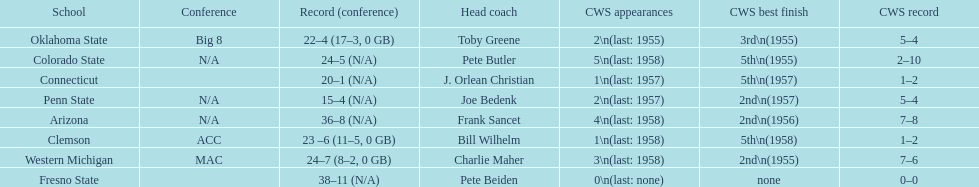How many teams had their cws best finish in 1955? 3. 